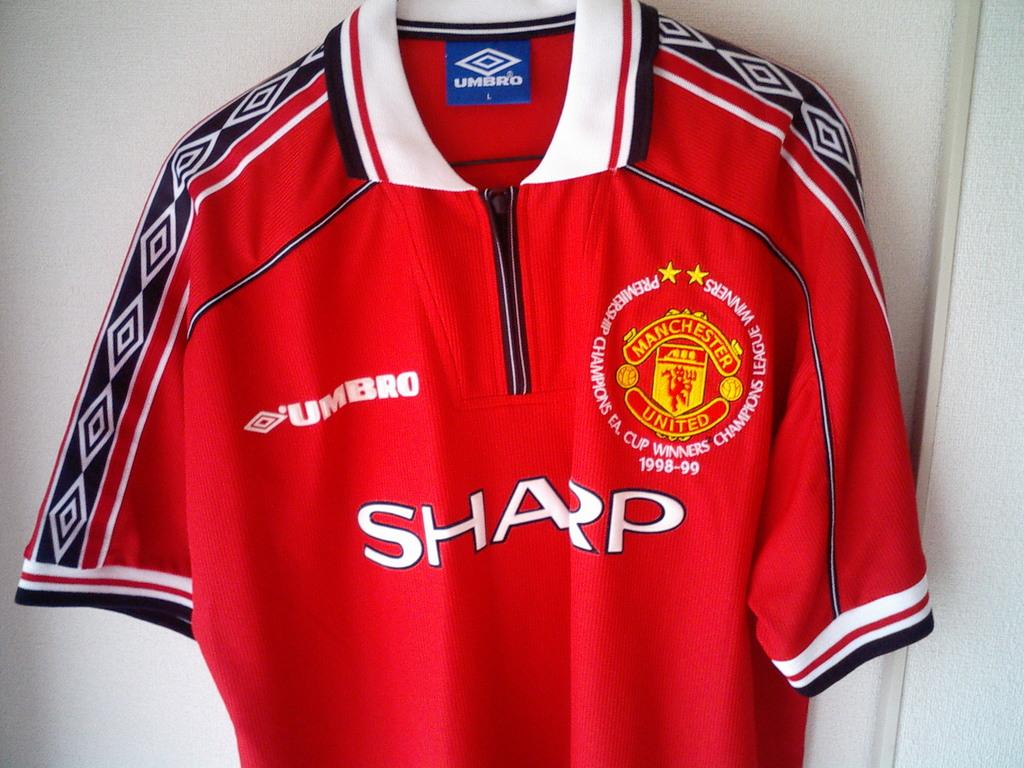Provide a one-sentence caption for the provided image. A red Manchester United shirt hangs against a white wall. 